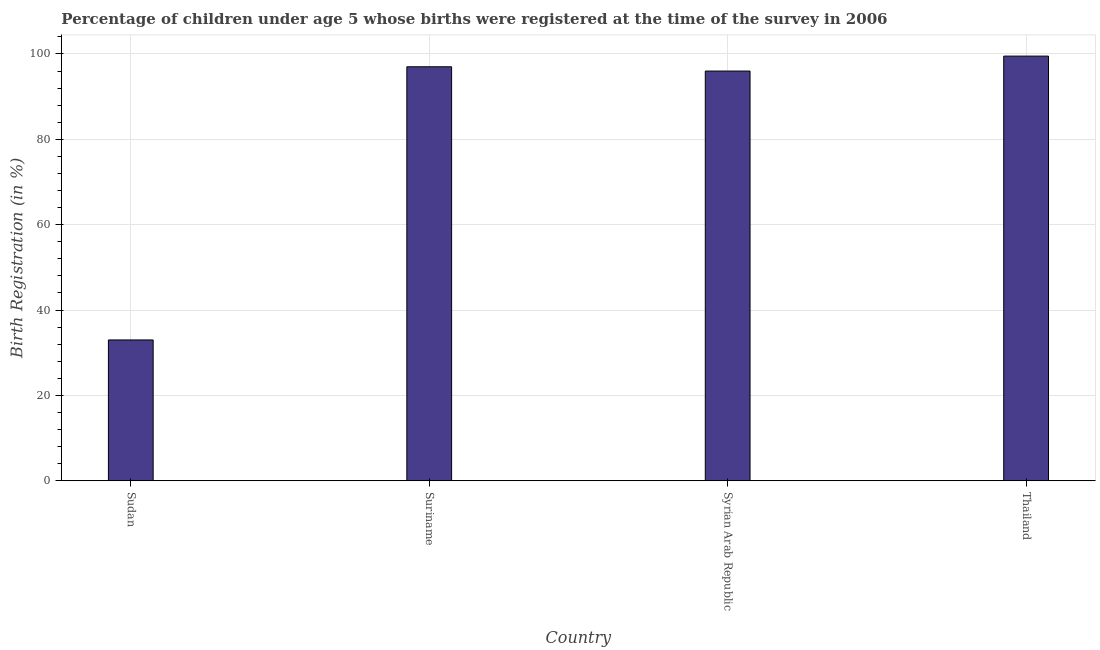What is the title of the graph?
Ensure brevity in your answer.  Percentage of children under age 5 whose births were registered at the time of the survey in 2006. What is the label or title of the Y-axis?
Offer a very short reply. Birth Registration (in %). What is the birth registration in Suriname?
Offer a terse response. 97. Across all countries, what is the maximum birth registration?
Your answer should be very brief. 99.5. In which country was the birth registration maximum?
Offer a very short reply. Thailand. In which country was the birth registration minimum?
Give a very brief answer. Sudan. What is the sum of the birth registration?
Provide a short and direct response. 325.5. What is the difference between the birth registration in Sudan and Suriname?
Make the answer very short. -64. What is the average birth registration per country?
Keep it short and to the point. 81.38. What is the median birth registration?
Ensure brevity in your answer.  96.5. What is the ratio of the birth registration in Sudan to that in Syrian Arab Republic?
Keep it short and to the point. 0.34. Is the difference between the birth registration in Suriname and Thailand greater than the difference between any two countries?
Provide a succinct answer. No. What is the difference between the highest and the second highest birth registration?
Offer a very short reply. 2.5. What is the difference between the highest and the lowest birth registration?
Make the answer very short. 66.5. Are all the bars in the graph horizontal?
Offer a terse response. No. How many countries are there in the graph?
Your response must be concise. 4. What is the difference between two consecutive major ticks on the Y-axis?
Your response must be concise. 20. Are the values on the major ticks of Y-axis written in scientific E-notation?
Your answer should be compact. No. What is the Birth Registration (in %) in Sudan?
Ensure brevity in your answer.  33. What is the Birth Registration (in %) of Suriname?
Ensure brevity in your answer.  97. What is the Birth Registration (in %) in Syrian Arab Republic?
Your answer should be very brief. 96. What is the Birth Registration (in %) of Thailand?
Offer a terse response. 99.5. What is the difference between the Birth Registration (in %) in Sudan and Suriname?
Offer a very short reply. -64. What is the difference between the Birth Registration (in %) in Sudan and Syrian Arab Republic?
Your answer should be compact. -63. What is the difference between the Birth Registration (in %) in Sudan and Thailand?
Provide a succinct answer. -66.5. What is the difference between the Birth Registration (in %) in Suriname and Syrian Arab Republic?
Your answer should be very brief. 1. What is the difference between the Birth Registration (in %) in Suriname and Thailand?
Offer a terse response. -2.5. What is the ratio of the Birth Registration (in %) in Sudan to that in Suriname?
Ensure brevity in your answer.  0.34. What is the ratio of the Birth Registration (in %) in Sudan to that in Syrian Arab Republic?
Your answer should be compact. 0.34. What is the ratio of the Birth Registration (in %) in Sudan to that in Thailand?
Your answer should be compact. 0.33. What is the ratio of the Birth Registration (in %) in Suriname to that in Syrian Arab Republic?
Keep it short and to the point. 1.01. What is the ratio of the Birth Registration (in %) in Suriname to that in Thailand?
Keep it short and to the point. 0.97. 